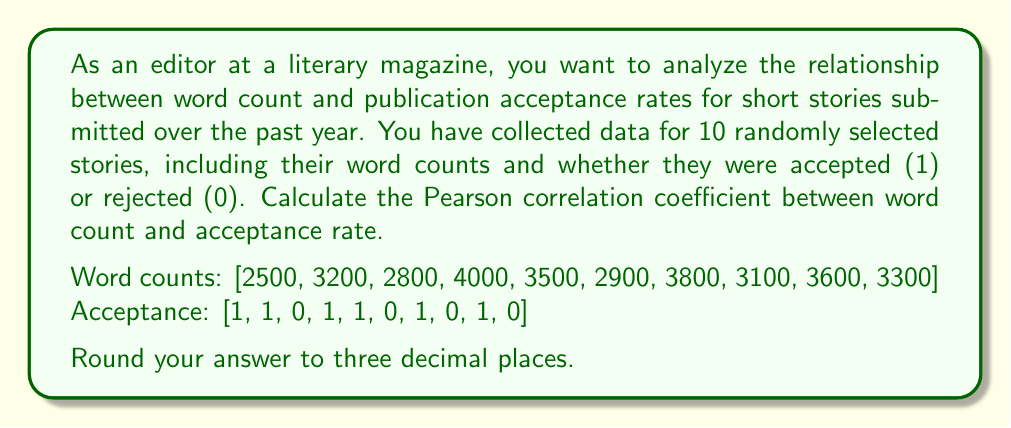Teach me how to tackle this problem. To calculate the Pearson correlation coefficient between word count and acceptance rate, we'll follow these steps:

1. Calculate the means of word count ($\bar{x}$) and acceptance ($\bar{y}$):

   $\bar{x} = \frac{2500 + 3200 + 2800 + 4000 + 3500 + 2900 + 3800 + 3100 + 3600 + 3300}{10} = 3270$
   $\bar{y} = \frac{1 + 1 + 0 + 1 + 1 + 0 + 1 + 0 + 1 + 0}{10} = 0.6$

2. Calculate the deviations from the mean for both variables:

   $x_i - \bar{x}$ and $y_i - \bar{y}$

3. Calculate the products of the deviations:

   $(x_i - \bar{x})(y_i - \bar{y})$

4. Sum the products of deviations:

   $\sum_{i=1}^{n} (x_i - \bar{x})(y_i - \bar{y})$

5. Calculate the sum of squared deviations for each variable:

   $\sum_{i=1}^{n} (x_i - \bar{x})^2$ and $\sum_{i=1}^{n} (y_i - \bar{y})^2$

6. Apply the Pearson correlation coefficient formula:

   $r = \frac{\sum_{i=1}^{n} (x_i - \bar{x})(y_i - \bar{y})}{\sqrt{\sum_{i=1}^{n} (x_i - \bar{x})^2 \sum_{i=1}^{n} (y_i - \bar{y})^2}}$

Calculating these values:

$\sum_{i=1}^{n} (x_i - \bar{x})(y_i - \bar{y}) = 98000$
$\sum_{i=1}^{n} (x_i - \bar{x})^2 = 1,701,000$
$\sum_{i=1}^{n} (y_i - \bar{y})^2 = 2.4$

Substituting into the formula:

$r = \frac{98000}{\sqrt{1701000 \times 2.4}} = \frac{98000}{2021.36} = 0.48481$

Rounding to three decimal places: 0.485
Answer: 0.485 